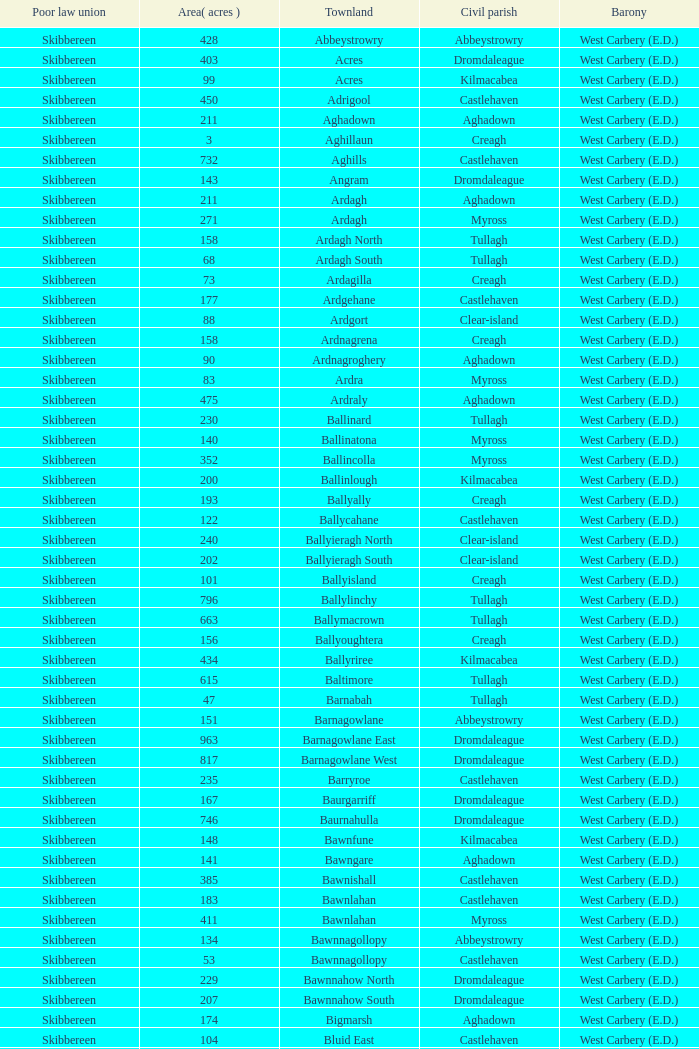What are the Poor Law Unions when the area (in acres) is 142? Skibbereen. 